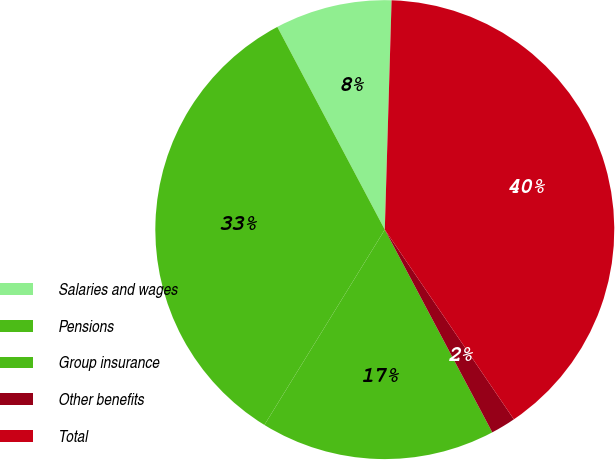Convert chart to OTSL. <chart><loc_0><loc_0><loc_500><loc_500><pie_chart><fcel>Salaries and wages<fcel>Pensions<fcel>Group insurance<fcel>Other benefits<fcel>Total<nl><fcel>8.23%<fcel>33.45%<fcel>16.55%<fcel>1.75%<fcel>40.02%<nl></chart> 